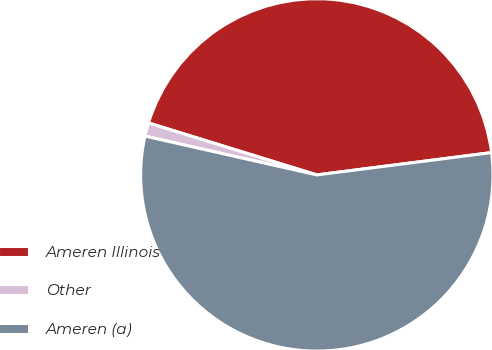Convert chart to OTSL. <chart><loc_0><loc_0><loc_500><loc_500><pie_chart><fcel>Ameren Illinois<fcel>Other<fcel>Ameren (a)<nl><fcel>43.21%<fcel>1.23%<fcel>55.56%<nl></chart> 